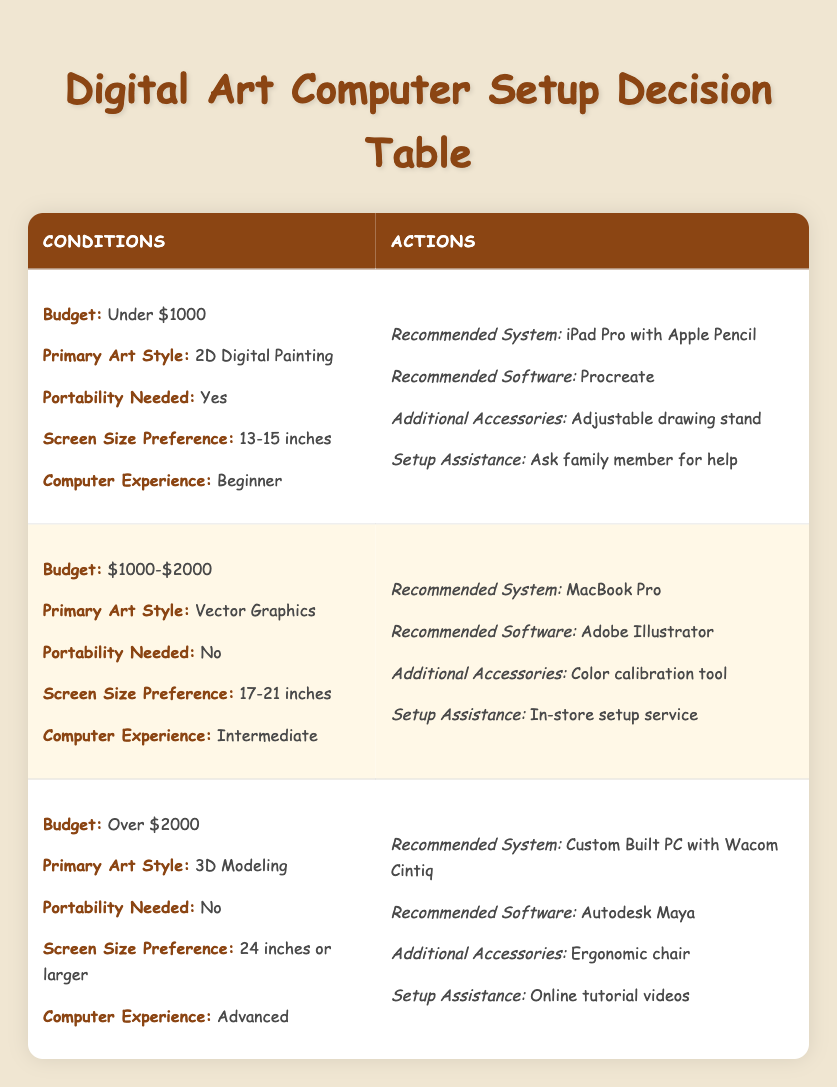What computer system is recommended for someone with a budget under $1000? Looking at the first row of the table, where the budget is specified as "Under $1000," the recommended system is "iPad Pro with Apple Pencil."
Answer: iPad Pro with Apple Pencil Is the recommended software for 3D modeling Autodesk Maya? In the third row where the budget is "Over $2000" and the primary art style is "3D Modeling," the recommended software is indeed "Autodesk Maya."
Answer: Yes For an intermediate artist who prefers vector graphics and has a budget of $1000-$2000, what accessories are recommended? Referring to the second row, the budget is "$1000-$2000," and the primary art style is "Vector Graphics." The recommended additional accessory is a "Color calibration tool."
Answer: Color calibration tool How many setups require "In-store setup service"? In the second row, it states "In-store setup service" for the conditions of a budget of "$1000-$2000," intermediate experience, vector graphics, and no portability needed. Thus, only one setup in the table requires this kind of assistance.
Answer: 1 If an advanced artist requires a large screen and prefers to do 3D modeling, what is the setup assistance provided? In the last row where the budget is "Over $2000," the screen size preference is "24 inches or larger," and the primary art style is "3D Modeling," the setup assistance provided is "Online tutorial videos."
Answer: Online tutorial videos What is the recommended system for an individual who is a beginner, has a budget under $1000, and needs portability? For someone who is a beginner with a budget under $1000 needing portability, the first row states that the recommended system is "iPad Pro with Apple Pencil."
Answer: iPad Pro with Apple Pencil Is there any recommended system for someone who needs portability and has a budget over $2000? Looking across the table, there are no rows where the budget is "Over $2000" that also indicate a need for portability; therefore, the answer is no.
Answer: No What is the relationship between computer experience and setup assistance for budgets over $2000? Observing the third row where the budget is "Over $2000," the experience level is "Advanced," and the setup assistance recommended is "Online tutorial videos." This indicates that as the experience increases, the reliance on online resources may be preferred.
Answer: Advanced experience relates to online tutorial videos 